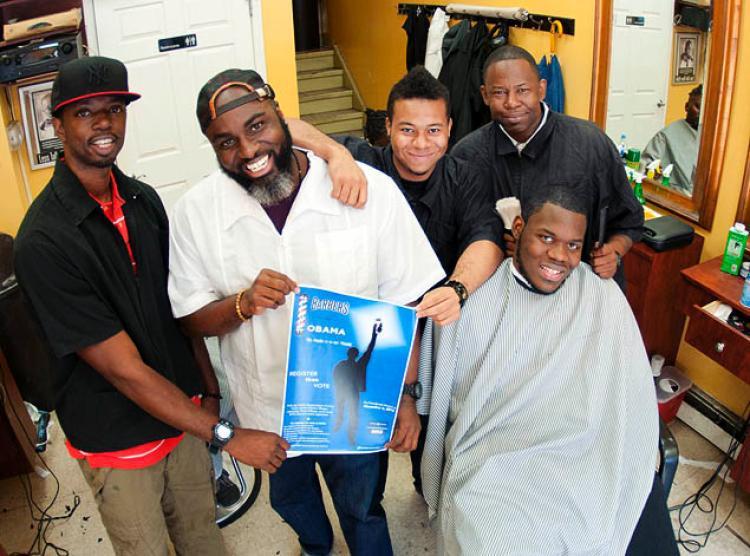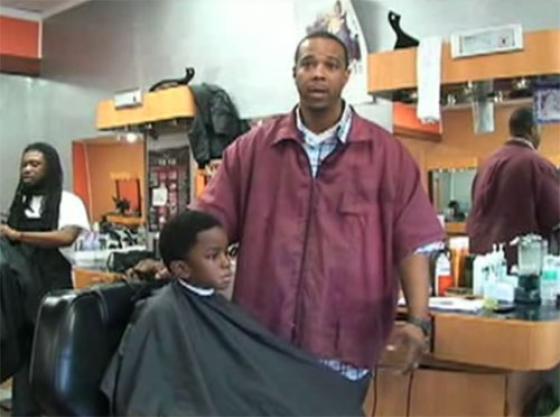The first image is the image on the left, the second image is the image on the right. For the images shown, is this caption "There are more people in the barber shop in the right image." true? Answer yes or no. No. 